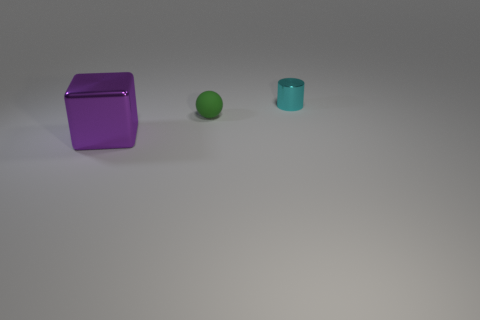Add 2 rubber spheres. How many objects exist? 5 Subtract all balls. How many objects are left? 2 Subtract all large gray shiny blocks. Subtract all cyan cylinders. How many objects are left? 2 Add 1 tiny green balls. How many tiny green balls are left? 2 Add 1 matte cubes. How many matte cubes exist? 1 Subtract 0 cyan balls. How many objects are left? 3 